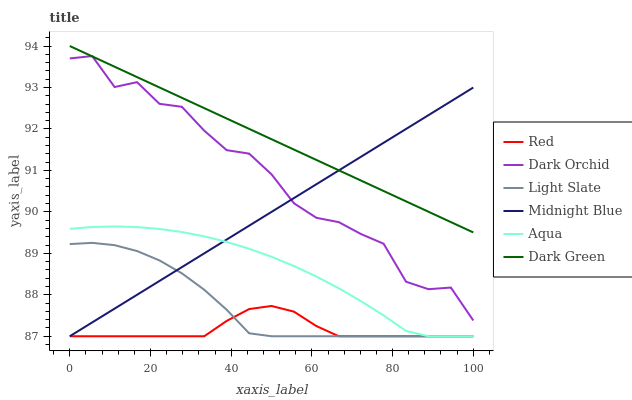Does Red have the minimum area under the curve?
Answer yes or no. Yes. Does Dark Green have the maximum area under the curve?
Answer yes or no. Yes. Does Light Slate have the minimum area under the curve?
Answer yes or no. No. Does Light Slate have the maximum area under the curve?
Answer yes or no. No. Is Dark Green the smoothest?
Answer yes or no. Yes. Is Dark Orchid the roughest?
Answer yes or no. Yes. Is Light Slate the smoothest?
Answer yes or no. No. Is Light Slate the roughest?
Answer yes or no. No. Does Dark Orchid have the lowest value?
Answer yes or no. No. Does Dark Green have the highest value?
Answer yes or no. Yes. Does Light Slate have the highest value?
Answer yes or no. No. Is Red less than Dark Orchid?
Answer yes or no. Yes. Is Dark Green greater than Red?
Answer yes or no. Yes. Does Red intersect Dark Orchid?
Answer yes or no. No. 